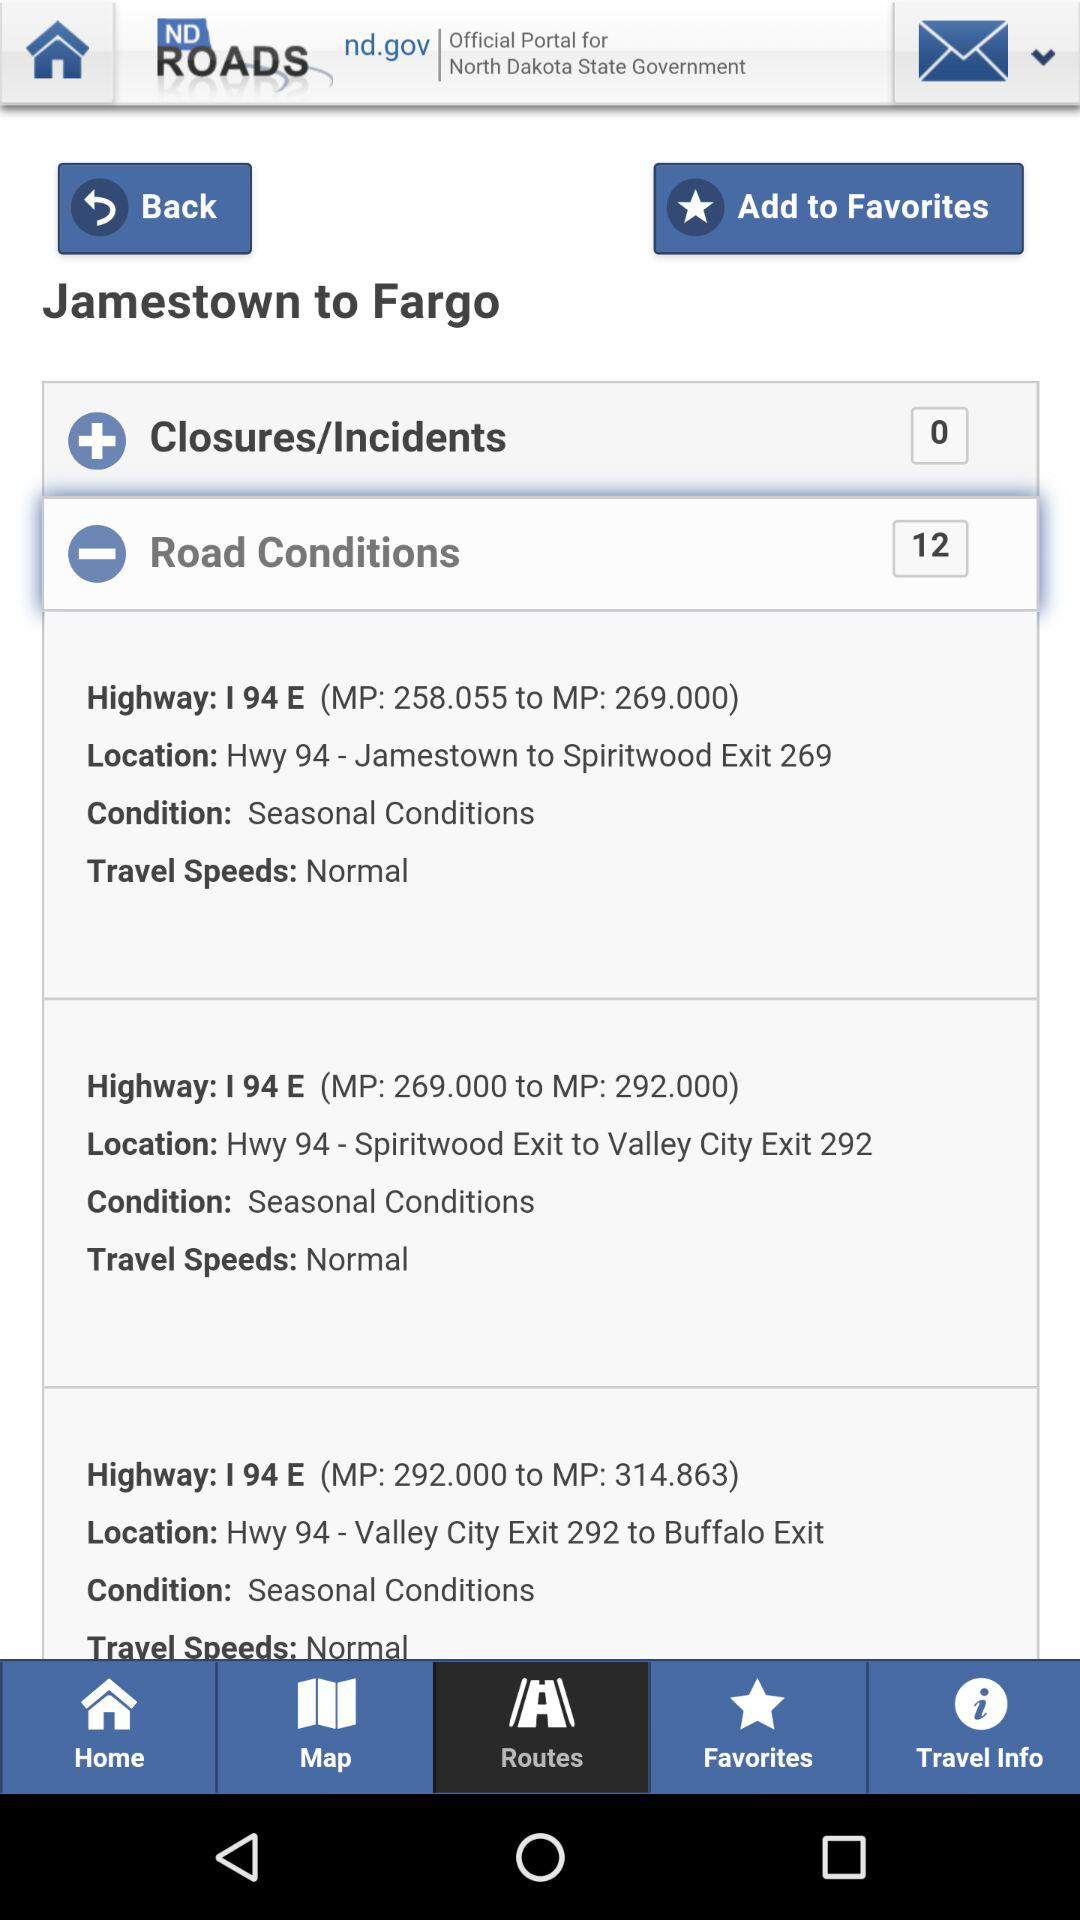Which highway connects Valley City Exit 292 to Buffalo Exit? It is connected by Highway 94. 